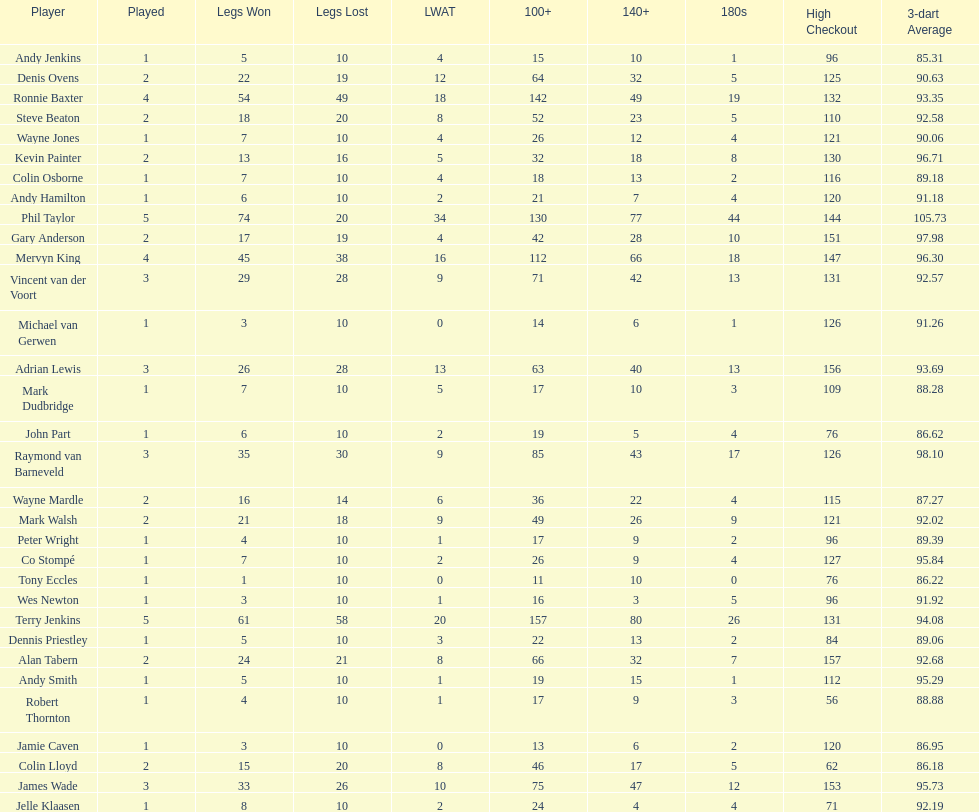How many players in the 2009 world matchplay won at least 30 legs? 6. 